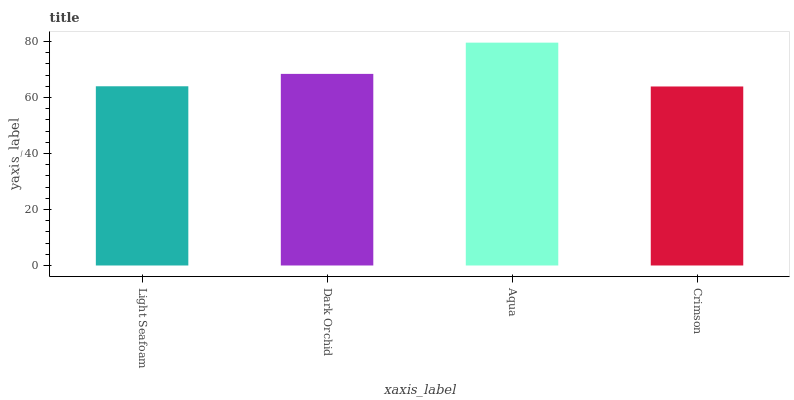Is Crimson the minimum?
Answer yes or no. Yes. Is Aqua the maximum?
Answer yes or no. Yes. Is Dark Orchid the minimum?
Answer yes or no. No. Is Dark Orchid the maximum?
Answer yes or no. No. Is Dark Orchid greater than Light Seafoam?
Answer yes or no. Yes. Is Light Seafoam less than Dark Orchid?
Answer yes or no. Yes. Is Light Seafoam greater than Dark Orchid?
Answer yes or no. No. Is Dark Orchid less than Light Seafoam?
Answer yes or no. No. Is Dark Orchid the high median?
Answer yes or no. Yes. Is Light Seafoam the low median?
Answer yes or no. Yes. Is Crimson the high median?
Answer yes or no. No. Is Dark Orchid the low median?
Answer yes or no. No. 